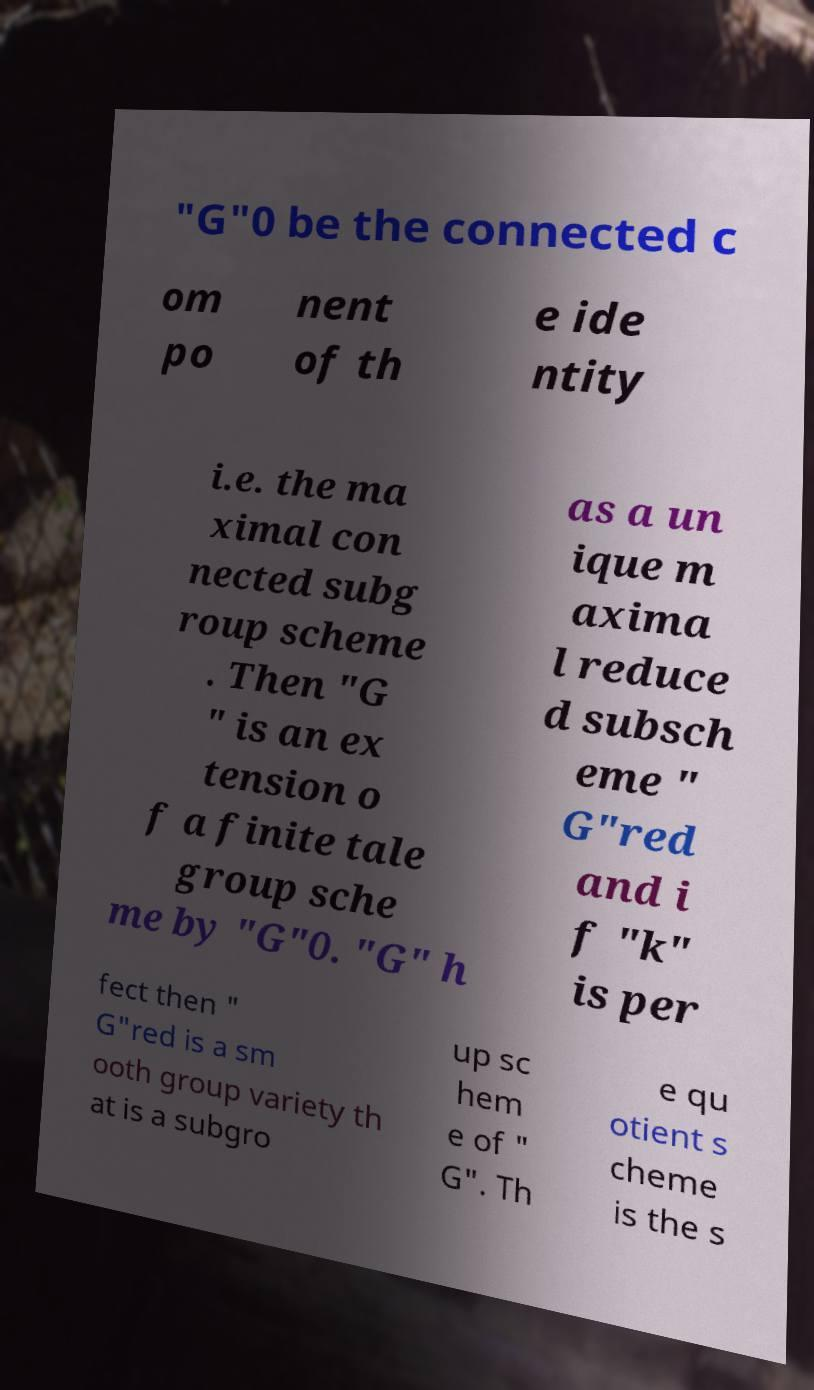Please read and relay the text visible in this image. What does it say? "G"0 be the connected c om po nent of th e ide ntity i.e. the ma ximal con nected subg roup scheme . Then "G " is an ex tension o f a finite tale group sche me by "G"0. "G" h as a un ique m axima l reduce d subsch eme " G"red and i f "k" is per fect then " G"red is a sm ooth group variety th at is a subgro up sc hem e of " G". Th e qu otient s cheme is the s 